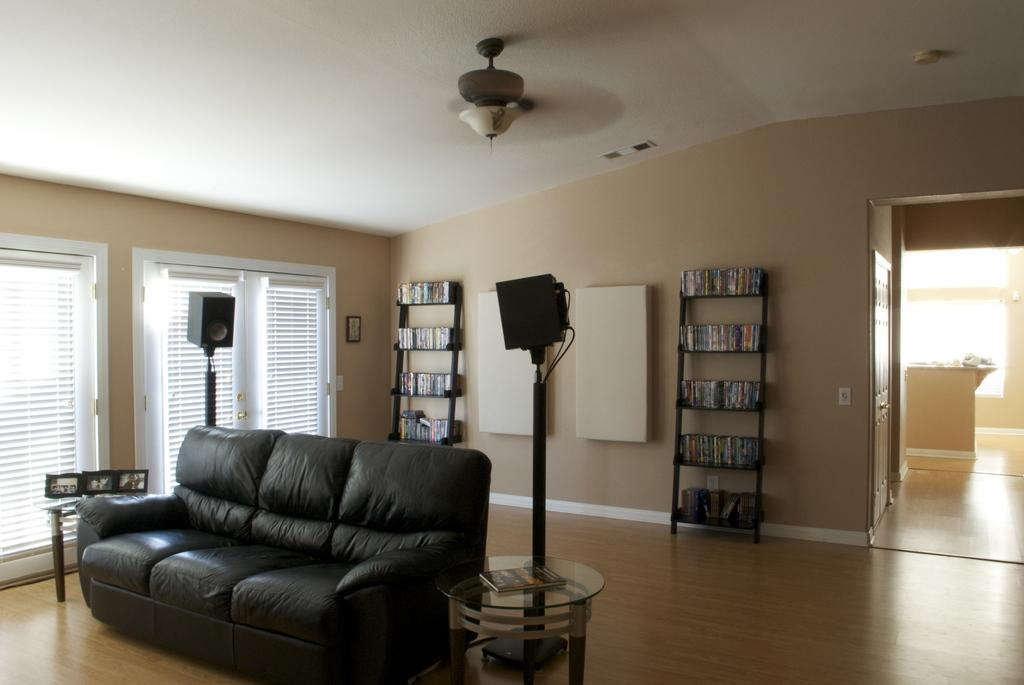What type of furniture is present in the image? There is a sofa and a table in the image. What is used for cooling in the image? There is a fan in the image. What can be seen on the wall in the image? There is a wall-to-wall shelf containing books in the image. What is visible on the wall that is not a shelf? There is a window in the image. What type of border is present in the image? There is no border present in the image. Is there a throne in the image? No, there is no throne in the image. 